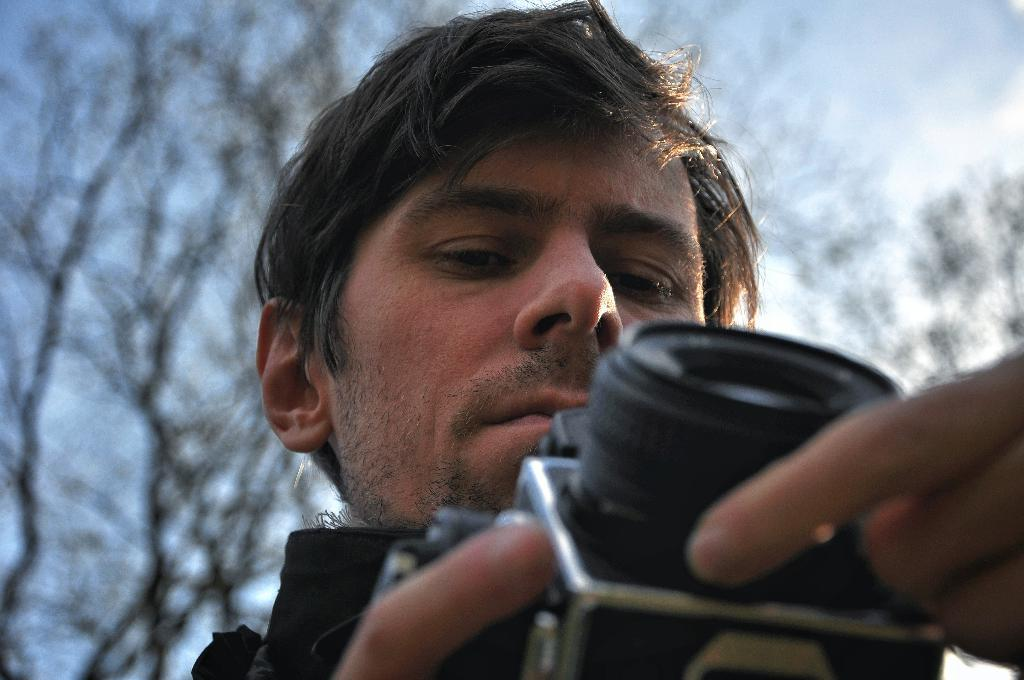Who is the main subject in the image? There is a man in the image. What is the man holding in the image? The man is holding a camera. What type of natural environment can be seen in the image? Trees and the sky are visible at the top of the image. What type of seed is the man planting in the image? There is no seed or planting activity present in the image. What type of drug is the man using in the image? There is no drug or drug use present in the image. 